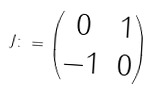<formula> <loc_0><loc_0><loc_500><loc_500>\ J \colon = \begin{pmatrix} 0 & 1 \\ - 1 & 0 \end{pmatrix}</formula> 